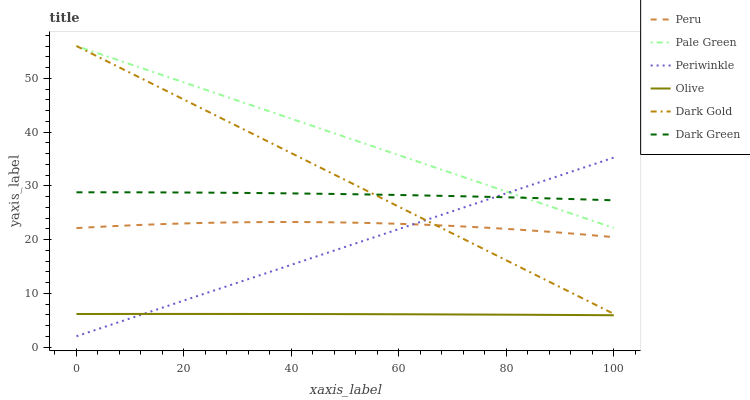Does Olive have the minimum area under the curve?
Answer yes or no. Yes. Does Pale Green have the maximum area under the curve?
Answer yes or no. Yes. Does Periwinkle have the minimum area under the curve?
Answer yes or no. No. Does Periwinkle have the maximum area under the curve?
Answer yes or no. No. Is Pale Green the smoothest?
Answer yes or no. Yes. Is Peru the roughest?
Answer yes or no. Yes. Is Periwinkle the smoothest?
Answer yes or no. No. Is Periwinkle the roughest?
Answer yes or no. No. Does Periwinkle have the lowest value?
Answer yes or no. Yes. Does Pale Green have the lowest value?
Answer yes or no. No. Does Pale Green have the highest value?
Answer yes or no. Yes. Does Periwinkle have the highest value?
Answer yes or no. No. Is Olive less than Dark Green?
Answer yes or no. Yes. Is Dark Gold greater than Olive?
Answer yes or no. Yes. Does Pale Green intersect Periwinkle?
Answer yes or no. Yes. Is Pale Green less than Periwinkle?
Answer yes or no. No. Is Pale Green greater than Periwinkle?
Answer yes or no. No. Does Olive intersect Dark Green?
Answer yes or no. No. 